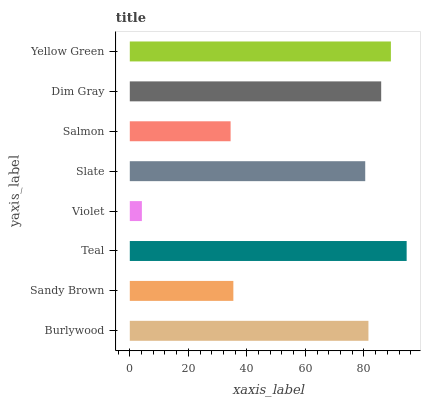Is Violet the minimum?
Answer yes or no. Yes. Is Teal the maximum?
Answer yes or no. Yes. Is Sandy Brown the minimum?
Answer yes or no. No. Is Sandy Brown the maximum?
Answer yes or no. No. Is Burlywood greater than Sandy Brown?
Answer yes or no. Yes. Is Sandy Brown less than Burlywood?
Answer yes or no. Yes. Is Sandy Brown greater than Burlywood?
Answer yes or no. No. Is Burlywood less than Sandy Brown?
Answer yes or no. No. Is Burlywood the high median?
Answer yes or no. Yes. Is Slate the low median?
Answer yes or no. Yes. Is Sandy Brown the high median?
Answer yes or no. No. Is Sandy Brown the low median?
Answer yes or no. No. 